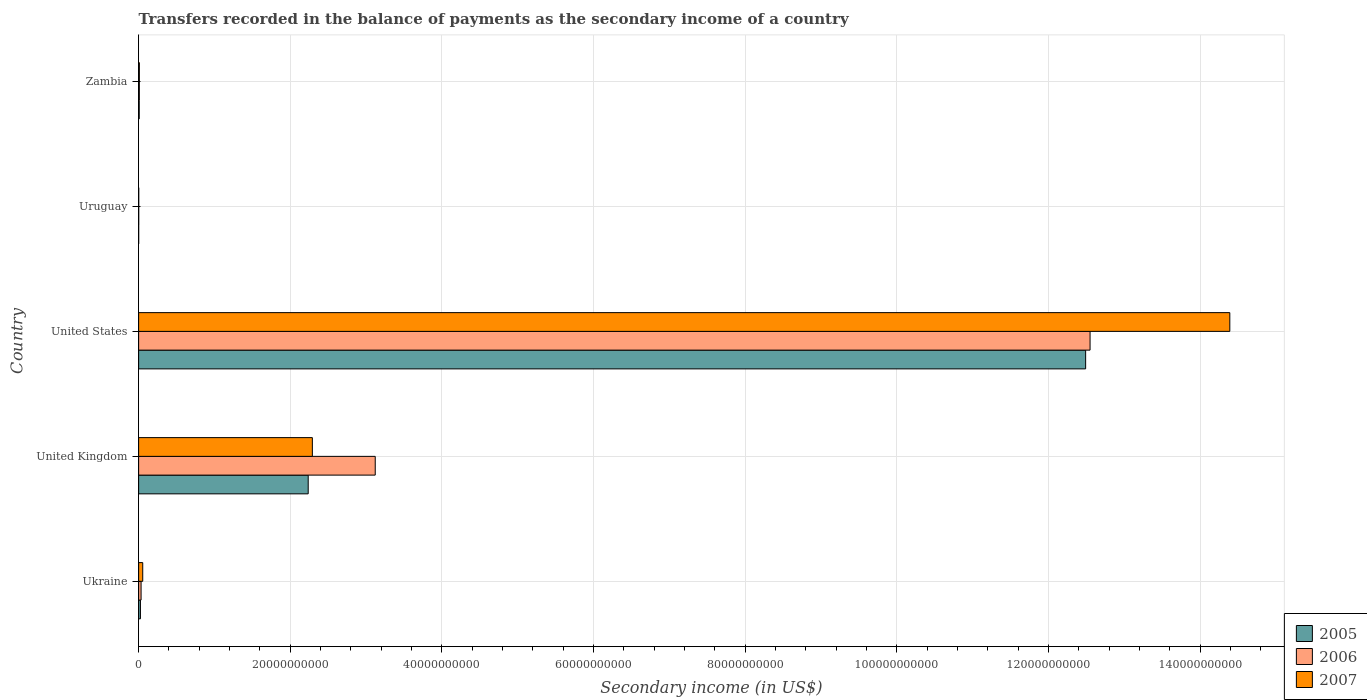How many different coloured bars are there?
Provide a succinct answer. 3. How many bars are there on the 4th tick from the top?
Your answer should be very brief. 3. What is the label of the 4th group of bars from the top?
Provide a succinct answer. United Kingdom. What is the secondary income of in 2006 in Uruguay?
Make the answer very short. 1.10e+07. Across all countries, what is the maximum secondary income of in 2006?
Offer a very short reply. 1.25e+11. Across all countries, what is the minimum secondary income of in 2006?
Offer a terse response. 1.10e+07. In which country was the secondary income of in 2007 minimum?
Keep it short and to the point. Uruguay. What is the total secondary income of in 2007 in the graph?
Offer a terse response. 1.67e+11. What is the difference between the secondary income of in 2006 in Ukraine and that in United Kingdom?
Your answer should be very brief. -3.09e+1. What is the difference between the secondary income of in 2006 in Ukraine and the secondary income of in 2005 in United States?
Your answer should be compact. -1.25e+11. What is the average secondary income of in 2007 per country?
Give a very brief answer. 3.35e+1. What is the difference between the secondary income of in 2005 and secondary income of in 2007 in Zambia?
Your answer should be compact. -1.89e+07. What is the ratio of the secondary income of in 2005 in Ukraine to that in Uruguay?
Your answer should be very brief. 39.12. Is the difference between the secondary income of in 2005 in United Kingdom and Uruguay greater than the difference between the secondary income of in 2007 in United Kingdom and Uruguay?
Your answer should be very brief. No. What is the difference between the highest and the second highest secondary income of in 2005?
Provide a succinct answer. 1.03e+11. What is the difference between the highest and the lowest secondary income of in 2006?
Provide a short and direct response. 1.25e+11. How many countries are there in the graph?
Provide a succinct answer. 5. What is the difference between two consecutive major ticks on the X-axis?
Your answer should be compact. 2.00e+1. Are the values on the major ticks of X-axis written in scientific E-notation?
Your answer should be compact. No. Does the graph contain grids?
Your answer should be very brief. Yes. How many legend labels are there?
Your answer should be very brief. 3. What is the title of the graph?
Your response must be concise. Transfers recorded in the balance of payments as the secondary income of a country. What is the label or title of the X-axis?
Your answer should be very brief. Secondary income (in US$). What is the Secondary income (in US$) of 2005 in Ukraine?
Provide a succinct answer. 2.39e+08. What is the Secondary income (in US$) in 2006 in Ukraine?
Offer a very short reply. 3.24e+08. What is the Secondary income (in US$) of 2007 in Ukraine?
Your answer should be compact. 5.42e+08. What is the Secondary income (in US$) in 2005 in United Kingdom?
Give a very brief answer. 2.24e+1. What is the Secondary income (in US$) in 2006 in United Kingdom?
Keep it short and to the point. 3.12e+1. What is the Secondary income (in US$) in 2007 in United Kingdom?
Your answer should be very brief. 2.29e+1. What is the Secondary income (in US$) in 2005 in United States?
Provide a short and direct response. 1.25e+11. What is the Secondary income (in US$) of 2006 in United States?
Ensure brevity in your answer.  1.25e+11. What is the Secondary income (in US$) of 2007 in United States?
Keep it short and to the point. 1.44e+11. What is the Secondary income (in US$) of 2005 in Uruguay?
Your response must be concise. 6.11e+06. What is the Secondary income (in US$) of 2006 in Uruguay?
Provide a succinct answer. 1.10e+07. What is the Secondary income (in US$) of 2007 in Uruguay?
Your response must be concise. 1.37e+07. What is the Secondary income (in US$) of 2005 in Zambia?
Give a very brief answer. 7.70e+07. What is the Secondary income (in US$) in 2006 in Zambia?
Your response must be concise. 9.27e+07. What is the Secondary income (in US$) in 2007 in Zambia?
Offer a terse response. 9.59e+07. Across all countries, what is the maximum Secondary income (in US$) of 2005?
Provide a succinct answer. 1.25e+11. Across all countries, what is the maximum Secondary income (in US$) of 2006?
Give a very brief answer. 1.25e+11. Across all countries, what is the maximum Secondary income (in US$) of 2007?
Give a very brief answer. 1.44e+11. Across all countries, what is the minimum Secondary income (in US$) in 2005?
Your response must be concise. 6.11e+06. Across all countries, what is the minimum Secondary income (in US$) of 2006?
Offer a terse response. 1.10e+07. Across all countries, what is the minimum Secondary income (in US$) in 2007?
Offer a terse response. 1.37e+07. What is the total Secondary income (in US$) of 2005 in the graph?
Offer a terse response. 1.48e+11. What is the total Secondary income (in US$) in 2006 in the graph?
Give a very brief answer. 1.57e+11. What is the total Secondary income (in US$) of 2007 in the graph?
Make the answer very short. 1.67e+11. What is the difference between the Secondary income (in US$) of 2005 in Ukraine and that in United Kingdom?
Offer a terse response. -2.21e+1. What is the difference between the Secondary income (in US$) of 2006 in Ukraine and that in United Kingdom?
Ensure brevity in your answer.  -3.09e+1. What is the difference between the Secondary income (in US$) in 2007 in Ukraine and that in United Kingdom?
Your answer should be very brief. -2.24e+1. What is the difference between the Secondary income (in US$) in 2005 in Ukraine and that in United States?
Your response must be concise. -1.25e+11. What is the difference between the Secondary income (in US$) in 2006 in Ukraine and that in United States?
Provide a short and direct response. -1.25e+11. What is the difference between the Secondary income (in US$) of 2007 in Ukraine and that in United States?
Provide a succinct answer. -1.43e+11. What is the difference between the Secondary income (in US$) of 2005 in Ukraine and that in Uruguay?
Keep it short and to the point. 2.33e+08. What is the difference between the Secondary income (in US$) of 2006 in Ukraine and that in Uruguay?
Provide a short and direct response. 3.13e+08. What is the difference between the Secondary income (in US$) of 2007 in Ukraine and that in Uruguay?
Give a very brief answer. 5.28e+08. What is the difference between the Secondary income (in US$) of 2005 in Ukraine and that in Zambia?
Your answer should be compact. 1.62e+08. What is the difference between the Secondary income (in US$) in 2006 in Ukraine and that in Zambia?
Provide a succinct answer. 2.31e+08. What is the difference between the Secondary income (in US$) of 2007 in Ukraine and that in Zambia?
Provide a succinct answer. 4.46e+08. What is the difference between the Secondary income (in US$) of 2005 in United Kingdom and that in United States?
Provide a short and direct response. -1.03e+11. What is the difference between the Secondary income (in US$) of 2006 in United Kingdom and that in United States?
Offer a terse response. -9.43e+1. What is the difference between the Secondary income (in US$) in 2007 in United Kingdom and that in United States?
Your answer should be compact. -1.21e+11. What is the difference between the Secondary income (in US$) of 2005 in United Kingdom and that in Uruguay?
Offer a very short reply. 2.24e+1. What is the difference between the Secondary income (in US$) in 2006 in United Kingdom and that in Uruguay?
Give a very brief answer. 3.12e+1. What is the difference between the Secondary income (in US$) in 2007 in United Kingdom and that in Uruguay?
Give a very brief answer. 2.29e+1. What is the difference between the Secondary income (in US$) of 2005 in United Kingdom and that in Zambia?
Offer a very short reply. 2.23e+1. What is the difference between the Secondary income (in US$) in 2006 in United Kingdom and that in Zambia?
Offer a very short reply. 3.11e+1. What is the difference between the Secondary income (in US$) in 2007 in United Kingdom and that in Zambia?
Offer a very short reply. 2.28e+1. What is the difference between the Secondary income (in US$) in 2005 in United States and that in Uruguay?
Provide a short and direct response. 1.25e+11. What is the difference between the Secondary income (in US$) of 2006 in United States and that in Uruguay?
Provide a succinct answer. 1.25e+11. What is the difference between the Secondary income (in US$) in 2007 in United States and that in Uruguay?
Make the answer very short. 1.44e+11. What is the difference between the Secondary income (in US$) of 2005 in United States and that in Zambia?
Provide a succinct answer. 1.25e+11. What is the difference between the Secondary income (in US$) in 2006 in United States and that in Zambia?
Ensure brevity in your answer.  1.25e+11. What is the difference between the Secondary income (in US$) of 2007 in United States and that in Zambia?
Keep it short and to the point. 1.44e+11. What is the difference between the Secondary income (in US$) of 2005 in Uruguay and that in Zambia?
Make the answer very short. -7.09e+07. What is the difference between the Secondary income (in US$) in 2006 in Uruguay and that in Zambia?
Your answer should be compact. -8.17e+07. What is the difference between the Secondary income (in US$) in 2007 in Uruguay and that in Zambia?
Make the answer very short. -8.22e+07. What is the difference between the Secondary income (in US$) of 2005 in Ukraine and the Secondary income (in US$) of 2006 in United Kingdom?
Ensure brevity in your answer.  -3.10e+1. What is the difference between the Secondary income (in US$) in 2005 in Ukraine and the Secondary income (in US$) in 2007 in United Kingdom?
Provide a short and direct response. -2.27e+1. What is the difference between the Secondary income (in US$) of 2006 in Ukraine and the Secondary income (in US$) of 2007 in United Kingdom?
Ensure brevity in your answer.  -2.26e+1. What is the difference between the Secondary income (in US$) in 2005 in Ukraine and the Secondary income (in US$) in 2006 in United States?
Your answer should be compact. -1.25e+11. What is the difference between the Secondary income (in US$) in 2005 in Ukraine and the Secondary income (in US$) in 2007 in United States?
Give a very brief answer. -1.44e+11. What is the difference between the Secondary income (in US$) in 2006 in Ukraine and the Secondary income (in US$) in 2007 in United States?
Make the answer very short. -1.44e+11. What is the difference between the Secondary income (in US$) of 2005 in Ukraine and the Secondary income (in US$) of 2006 in Uruguay?
Make the answer very short. 2.28e+08. What is the difference between the Secondary income (in US$) in 2005 in Ukraine and the Secondary income (in US$) in 2007 in Uruguay?
Provide a succinct answer. 2.25e+08. What is the difference between the Secondary income (in US$) in 2006 in Ukraine and the Secondary income (in US$) in 2007 in Uruguay?
Provide a succinct answer. 3.10e+08. What is the difference between the Secondary income (in US$) in 2005 in Ukraine and the Secondary income (in US$) in 2006 in Zambia?
Your response must be concise. 1.46e+08. What is the difference between the Secondary income (in US$) in 2005 in Ukraine and the Secondary income (in US$) in 2007 in Zambia?
Your answer should be very brief. 1.43e+08. What is the difference between the Secondary income (in US$) of 2006 in Ukraine and the Secondary income (in US$) of 2007 in Zambia?
Provide a short and direct response. 2.28e+08. What is the difference between the Secondary income (in US$) in 2005 in United Kingdom and the Secondary income (in US$) in 2006 in United States?
Provide a short and direct response. -1.03e+11. What is the difference between the Secondary income (in US$) in 2005 in United Kingdom and the Secondary income (in US$) in 2007 in United States?
Ensure brevity in your answer.  -1.22e+11. What is the difference between the Secondary income (in US$) of 2006 in United Kingdom and the Secondary income (in US$) of 2007 in United States?
Provide a succinct answer. -1.13e+11. What is the difference between the Secondary income (in US$) in 2005 in United Kingdom and the Secondary income (in US$) in 2006 in Uruguay?
Provide a succinct answer. 2.24e+1. What is the difference between the Secondary income (in US$) in 2005 in United Kingdom and the Secondary income (in US$) in 2007 in Uruguay?
Provide a short and direct response. 2.23e+1. What is the difference between the Secondary income (in US$) in 2006 in United Kingdom and the Secondary income (in US$) in 2007 in Uruguay?
Ensure brevity in your answer.  3.12e+1. What is the difference between the Secondary income (in US$) in 2005 in United Kingdom and the Secondary income (in US$) in 2006 in Zambia?
Ensure brevity in your answer.  2.23e+1. What is the difference between the Secondary income (in US$) in 2005 in United Kingdom and the Secondary income (in US$) in 2007 in Zambia?
Your answer should be compact. 2.23e+1. What is the difference between the Secondary income (in US$) of 2006 in United Kingdom and the Secondary income (in US$) of 2007 in Zambia?
Your response must be concise. 3.11e+1. What is the difference between the Secondary income (in US$) in 2005 in United States and the Secondary income (in US$) in 2006 in Uruguay?
Offer a very short reply. 1.25e+11. What is the difference between the Secondary income (in US$) of 2005 in United States and the Secondary income (in US$) of 2007 in Uruguay?
Provide a succinct answer. 1.25e+11. What is the difference between the Secondary income (in US$) of 2006 in United States and the Secondary income (in US$) of 2007 in Uruguay?
Make the answer very short. 1.25e+11. What is the difference between the Secondary income (in US$) of 2005 in United States and the Secondary income (in US$) of 2006 in Zambia?
Your answer should be very brief. 1.25e+11. What is the difference between the Secondary income (in US$) in 2005 in United States and the Secondary income (in US$) in 2007 in Zambia?
Give a very brief answer. 1.25e+11. What is the difference between the Secondary income (in US$) of 2006 in United States and the Secondary income (in US$) of 2007 in Zambia?
Give a very brief answer. 1.25e+11. What is the difference between the Secondary income (in US$) in 2005 in Uruguay and the Secondary income (in US$) in 2006 in Zambia?
Your answer should be compact. -8.66e+07. What is the difference between the Secondary income (in US$) in 2005 in Uruguay and the Secondary income (in US$) in 2007 in Zambia?
Keep it short and to the point. -8.98e+07. What is the difference between the Secondary income (in US$) of 2006 in Uruguay and the Secondary income (in US$) of 2007 in Zambia?
Make the answer very short. -8.49e+07. What is the average Secondary income (in US$) of 2005 per country?
Your answer should be very brief. 2.95e+1. What is the average Secondary income (in US$) in 2006 per country?
Your answer should be compact. 3.14e+1. What is the average Secondary income (in US$) of 2007 per country?
Your answer should be very brief. 3.35e+1. What is the difference between the Secondary income (in US$) in 2005 and Secondary income (in US$) in 2006 in Ukraine?
Provide a short and direct response. -8.50e+07. What is the difference between the Secondary income (in US$) of 2005 and Secondary income (in US$) of 2007 in Ukraine?
Your answer should be very brief. -3.03e+08. What is the difference between the Secondary income (in US$) of 2006 and Secondary income (in US$) of 2007 in Ukraine?
Provide a short and direct response. -2.18e+08. What is the difference between the Secondary income (in US$) of 2005 and Secondary income (in US$) of 2006 in United Kingdom?
Provide a succinct answer. -8.84e+09. What is the difference between the Secondary income (in US$) of 2005 and Secondary income (in US$) of 2007 in United Kingdom?
Make the answer very short. -5.48e+08. What is the difference between the Secondary income (in US$) in 2006 and Secondary income (in US$) in 2007 in United Kingdom?
Make the answer very short. 8.29e+09. What is the difference between the Secondary income (in US$) in 2005 and Secondary income (in US$) in 2006 in United States?
Ensure brevity in your answer.  -5.83e+08. What is the difference between the Secondary income (in US$) in 2005 and Secondary income (in US$) in 2007 in United States?
Your answer should be very brief. -1.90e+1. What is the difference between the Secondary income (in US$) of 2006 and Secondary income (in US$) of 2007 in United States?
Keep it short and to the point. -1.84e+1. What is the difference between the Secondary income (in US$) of 2005 and Secondary income (in US$) of 2006 in Uruguay?
Provide a succinct answer. -4.93e+06. What is the difference between the Secondary income (in US$) of 2005 and Secondary income (in US$) of 2007 in Uruguay?
Offer a very short reply. -7.60e+06. What is the difference between the Secondary income (in US$) of 2006 and Secondary income (in US$) of 2007 in Uruguay?
Your answer should be very brief. -2.67e+06. What is the difference between the Secondary income (in US$) of 2005 and Secondary income (in US$) of 2006 in Zambia?
Provide a succinct answer. -1.58e+07. What is the difference between the Secondary income (in US$) in 2005 and Secondary income (in US$) in 2007 in Zambia?
Ensure brevity in your answer.  -1.89e+07. What is the difference between the Secondary income (in US$) of 2006 and Secondary income (in US$) of 2007 in Zambia?
Make the answer very short. -3.16e+06. What is the ratio of the Secondary income (in US$) of 2005 in Ukraine to that in United Kingdom?
Your answer should be very brief. 0.01. What is the ratio of the Secondary income (in US$) in 2006 in Ukraine to that in United Kingdom?
Make the answer very short. 0.01. What is the ratio of the Secondary income (in US$) in 2007 in Ukraine to that in United Kingdom?
Give a very brief answer. 0.02. What is the ratio of the Secondary income (in US$) of 2005 in Ukraine to that in United States?
Keep it short and to the point. 0. What is the ratio of the Secondary income (in US$) of 2006 in Ukraine to that in United States?
Offer a terse response. 0. What is the ratio of the Secondary income (in US$) of 2007 in Ukraine to that in United States?
Give a very brief answer. 0. What is the ratio of the Secondary income (in US$) in 2005 in Ukraine to that in Uruguay?
Give a very brief answer. 39.12. What is the ratio of the Secondary income (in US$) of 2006 in Ukraine to that in Uruguay?
Offer a very short reply. 29.34. What is the ratio of the Secondary income (in US$) in 2007 in Ukraine to that in Uruguay?
Offer a terse response. 39.53. What is the ratio of the Secondary income (in US$) in 2005 in Ukraine to that in Zambia?
Provide a short and direct response. 3.11. What is the ratio of the Secondary income (in US$) of 2006 in Ukraine to that in Zambia?
Offer a very short reply. 3.49. What is the ratio of the Secondary income (in US$) of 2007 in Ukraine to that in Zambia?
Your answer should be very brief. 5.65. What is the ratio of the Secondary income (in US$) of 2005 in United Kingdom to that in United States?
Ensure brevity in your answer.  0.18. What is the ratio of the Secondary income (in US$) in 2006 in United Kingdom to that in United States?
Your answer should be very brief. 0.25. What is the ratio of the Secondary income (in US$) of 2007 in United Kingdom to that in United States?
Provide a short and direct response. 0.16. What is the ratio of the Secondary income (in US$) of 2005 in United Kingdom to that in Uruguay?
Offer a terse response. 3660.45. What is the ratio of the Secondary income (in US$) of 2006 in United Kingdom to that in Uruguay?
Your answer should be very brief. 2825.35. What is the ratio of the Secondary income (in US$) in 2007 in United Kingdom to that in Uruguay?
Provide a succinct answer. 1670.79. What is the ratio of the Secondary income (in US$) in 2005 in United Kingdom to that in Zambia?
Offer a terse response. 290.55. What is the ratio of the Secondary income (in US$) in 2006 in United Kingdom to that in Zambia?
Give a very brief answer. 336.44. What is the ratio of the Secondary income (in US$) in 2007 in United Kingdom to that in Zambia?
Offer a very short reply. 238.89. What is the ratio of the Secondary income (in US$) of 2005 in United States to that in Uruguay?
Ensure brevity in your answer.  2.04e+04. What is the ratio of the Secondary income (in US$) of 2006 in United States to that in Uruguay?
Offer a very short reply. 1.14e+04. What is the ratio of the Secondary income (in US$) of 2007 in United States to that in Uruguay?
Your answer should be compact. 1.05e+04. What is the ratio of the Secondary income (in US$) of 2005 in United States to that in Zambia?
Offer a terse response. 1622.64. What is the ratio of the Secondary income (in US$) of 2006 in United States to that in Zambia?
Offer a terse response. 1352.91. What is the ratio of the Secondary income (in US$) in 2007 in United States to that in Zambia?
Provide a short and direct response. 1500.45. What is the ratio of the Secondary income (in US$) in 2005 in Uruguay to that in Zambia?
Make the answer very short. 0.08. What is the ratio of the Secondary income (in US$) in 2006 in Uruguay to that in Zambia?
Give a very brief answer. 0.12. What is the ratio of the Secondary income (in US$) of 2007 in Uruguay to that in Zambia?
Ensure brevity in your answer.  0.14. What is the difference between the highest and the second highest Secondary income (in US$) of 2005?
Offer a very short reply. 1.03e+11. What is the difference between the highest and the second highest Secondary income (in US$) of 2006?
Ensure brevity in your answer.  9.43e+1. What is the difference between the highest and the second highest Secondary income (in US$) in 2007?
Your response must be concise. 1.21e+11. What is the difference between the highest and the lowest Secondary income (in US$) in 2005?
Provide a short and direct response. 1.25e+11. What is the difference between the highest and the lowest Secondary income (in US$) in 2006?
Your response must be concise. 1.25e+11. What is the difference between the highest and the lowest Secondary income (in US$) of 2007?
Give a very brief answer. 1.44e+11. 